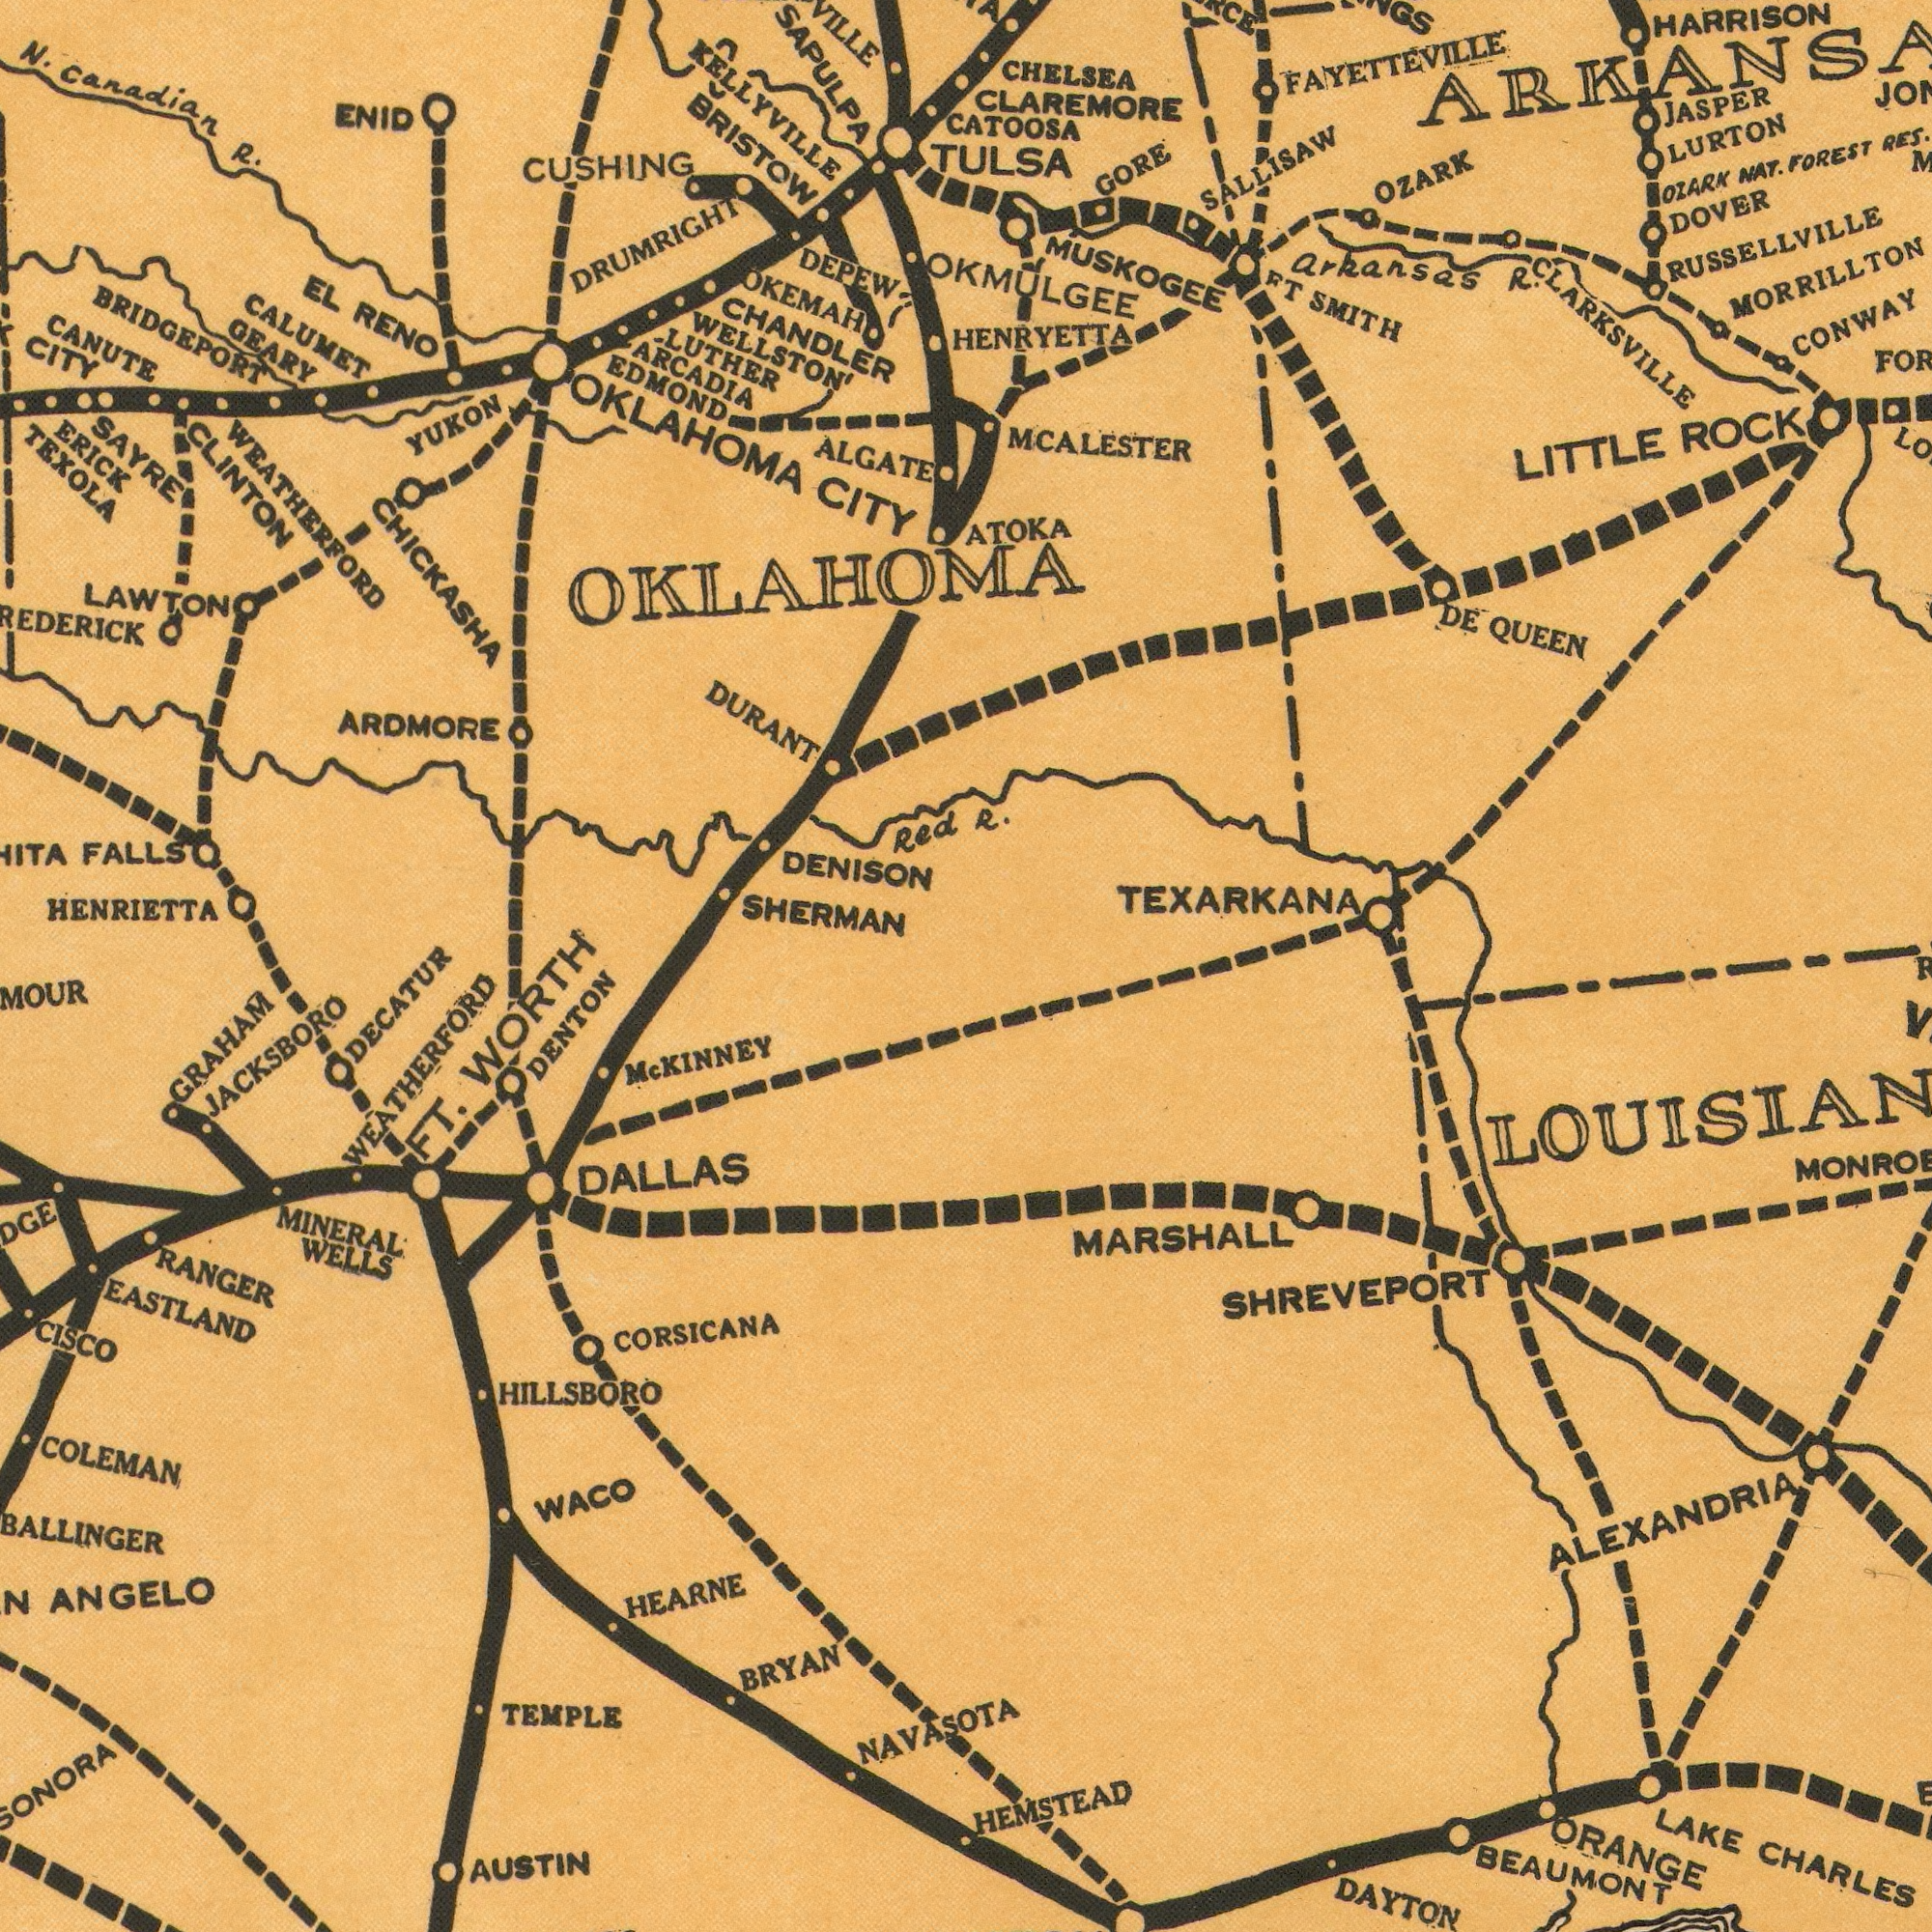What text is visible in the lower-right corner? HEMSTEAD BEAUMONT MARSHALL LAKE CHARLES ORANGE ALEXANDRIA DAYTON SHREVEPORT R V What text appears in the bottom-left area of the image? BALLINGER EASTLAND ANGELO HILLSBORO TEMPLE WACO Mc KINNEY RANGER MINERAL WELLS BRYAN COLEMAN CISCO HEARNE DENTON AUSTIN FT. WORTH WEATHERFORD CORSICANA DALLAS JACKSBORO GRAHAM NAVASOTA DECATUR What text can you see in the top-left section? HENRIETTA SAPULPA TEXOLA BRISTOW CUSHING DENISON CANUTE N. Canadian R. BRIDGEPORT ARDMORE SHERMAN DEPEW ALGATE GEARY OKLAHOMA CITY ERICK DURANT CITY YUKON LUTHER EL RENO FALLS ARCADIA OKEMAH WELLSTON' CHICKASHA EDMOND KELLYVILLE ENID LAWTON CHANDLER CLINTON WEATHERFORD SAYRE DRUMRIGHT CALUMET Red OKLAHOMA What text can you see in the top-right section? R. MCALESTER TEXARKANA FAYETTEVILLE CHELSEA CLAREMORE MUSKOGEE JASPER SALLISAW HARRISON CONWAY LURTON TULSA LITTLE ROCK OZARK ATOKA HENRYETTA GORE OZARK NAT. FOREST RES. DOVER DE QUEEN CATOOSA FT SMITH Arkansas R. RUSSELLVILLE OKMULGEE MORRILLTON CLARKSSVILE 